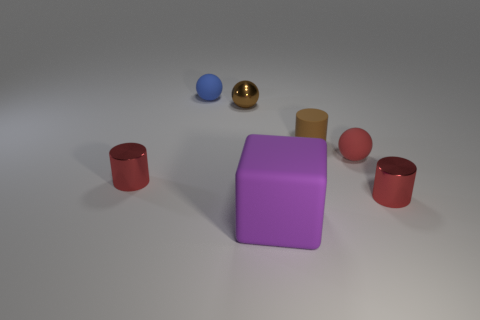Subtract all rubber spheres. How many spheres are left? 1 Subtract all gray blocks. How many red cylinders are left? 2 Subtract 1 cylinders. How many cylinders are left? 2 Add 2 big red metallic objects. How many objects exist? 9 Subtract all cylinders. How many objects are left? 4 Subtract all red rubber spheres. Subtract all matte cylinders. How many objects are left? 5 Add 3 red cylinders. How many red cylinders are left? 5 Add 3 brown objects. How many brown objects exist? 5 Subtract 0 cyan spheres. How many objects are left? 7 